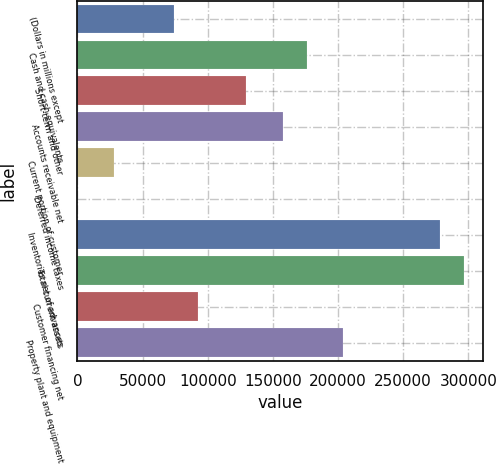<chart> <loc_0><loc_0><loc_500><loc_500><bar_chart><fcel>(Dollars in millions except<fcel>Cash and cash equivalents<fcel>Short-term and other<fcel>Accounts receivable net<fcel>Current portion of customer<fcel>Deferred income taxes<fcel>Inventories net of advances<fcel>Total current assets<fcel>Customer financing net<fcel>Property plant and equipment<nl><fcel>74133.2<fcel>176047<fcel>129723<fcel>157517<fcel>27808.7<fcel>14<fcel>277961<fcel>296491<fcel>92663<fcel>203842<nl></chart> 